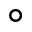Convert formula to latex. <formula><loc_0><loc_0><loc_500><loc_500>^ { \circ }</formula> 